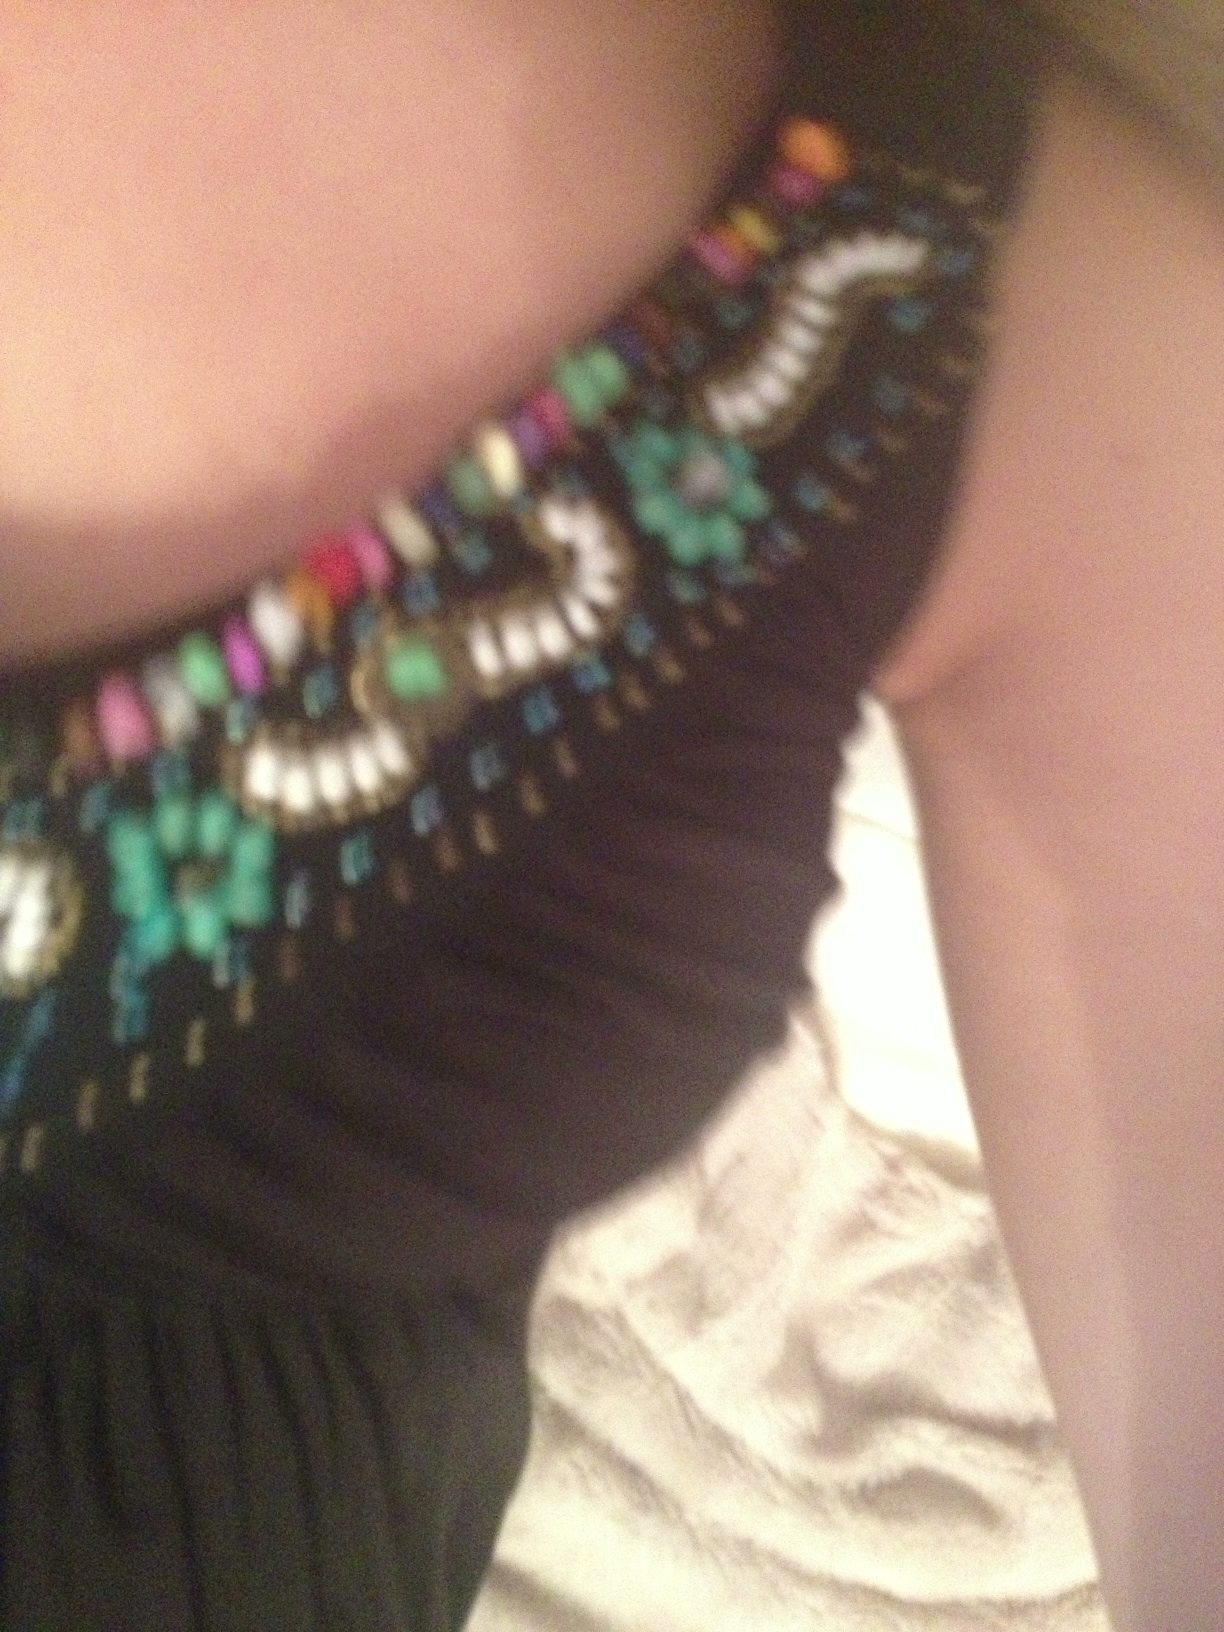What types of fabrics would complement the texture of this dress? To complement the dress's embellishments, opt for soft and smooth fabric types for your sweater, such as fine wool or cashmere. They would provide a subtle contrast and are luxurious, yet comfortable, choices for a cohesive outfit. 